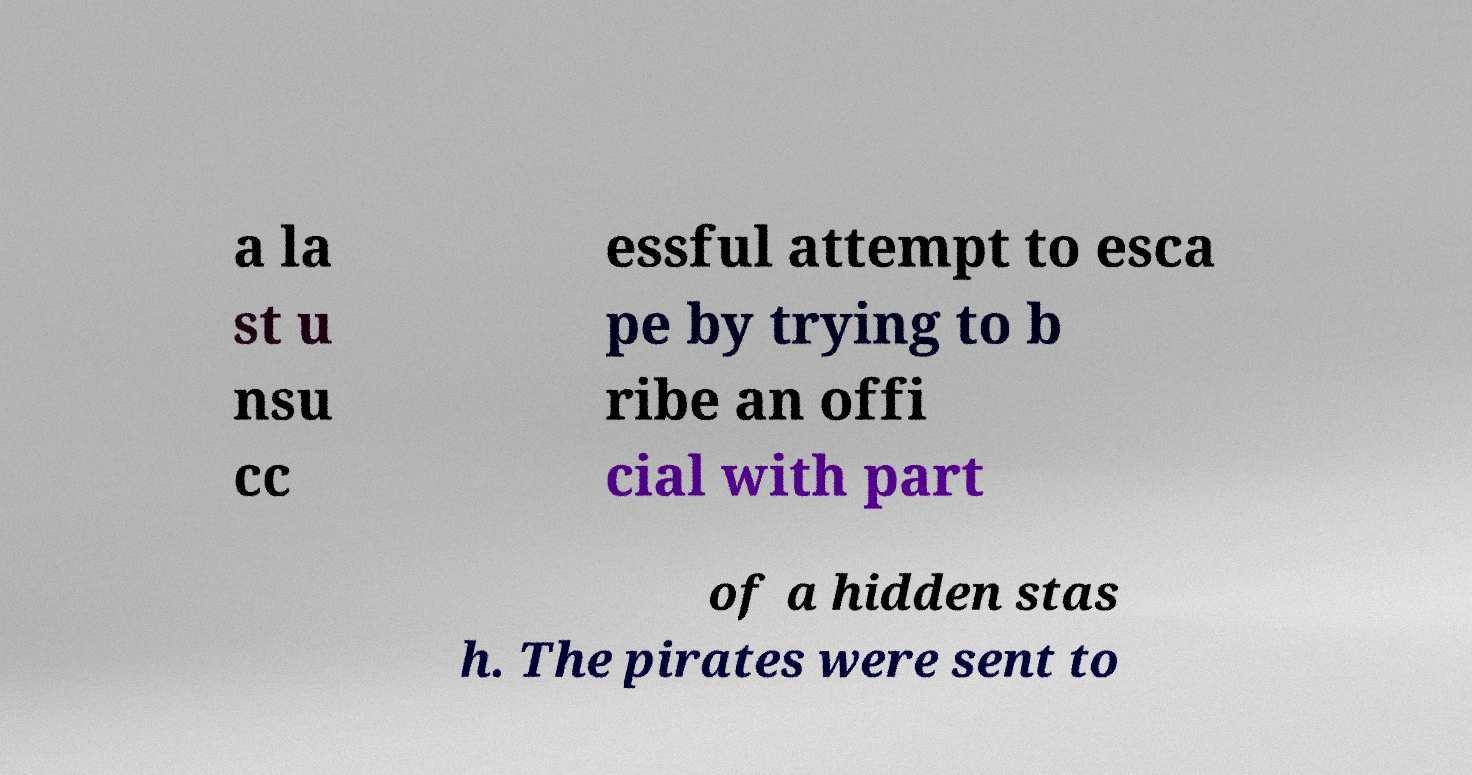Please read and relay the text visible in this image. What does it say? a la st u nsu cc essful attempt to esca pe by trying to b ribe an offi cial with part of a hidden stas h. The pirates were sent to 